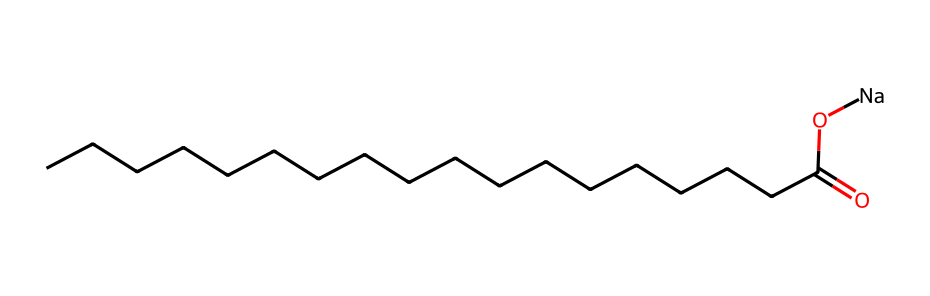What is the total number of carbon atoms in this molecule? The SMILES representation indicates a long chain of carbon (represented by 'C') atoms. By counting the 'C's in the chain before the functional group (the carboxylic acid part) and including the carbon from the carboxylate group 'CCCCCCCCCCCCCCCCCC(=O)', there are 18 carbon atoms in total.
Answer: 18 What type of functional group does this molecule contain? The structure contains a '-COO[Na]' group, indicating that it is a sodium salt of a carboxylic acid. The presence of the carbonyl '(=O)' and hydroxyl '(-O)' part of the group confirms it has a carboxylic acid functional group.
Answer: carboxylate Is this molecule likely to be hydrophilic or hydrophobic? Given the long carbon chain and the presence of the polar carboxylate group, this molecule exhibits both hydrophobic properties due to the long carbon chain and hydrophilic properties due to the carboxylate group. However, the predominant hydrophobic character often makes it hydrophobic in nature overall, typical for surfactants.
Answer: amphiphilic How many oxygen atoms are present in this molecule? In the carboxylate functional group ('-COO[Na]'), there are 2 oxygen atoms from the carboxylate and none in the hydrocarbon chain, leading to a total count of 2 oxygen atoms.
Answer: 2 What is the expected role of this molecule in cleaning products? This molecule serves as a surfactant, which helps reduce surface tension in water, allowing it to better interact with dirt and oils. The unique structure helps in emulsifying or dispersing oils in water, making it effective for cleaning.
Answer: surfactant How does the structure indicate its surfactant properties? The molecular structure showcases a long hydrophobic carbon chain and a charged hydrophilic carboxylate group. This duality allows it to interact with both water and oil, which is essential for the function of surfactants in products like soap.
Answer: duality 